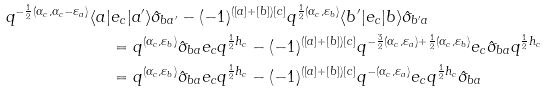Convert formula to latex. <formula><loc_0><loc_0><loc_500><loc_500>q ^ { - \frac { 1 } { 2 } ( \alpha _ { c } , \alpha _ { c } - \varepsilon _ { a } ) } \langle a | & e _ { c } | a ^ { \prime } \rangle \hat { \sigma } _ { b a ^ { \prime } } - ( - 1 ) ^ { ( [ a ] + [ b ] ) [ c ] } q ^ { \frac { 1 } { 2 } ( \alpha _ { c } , \varepsilon _ { b } ) } \langle b ^ { \prime } | e _ { c } | b \rangle \hat { \sigma } _ { b ^ { \prime } a } \\ & = q ^ { ( \alpha _ { c } , \varepsilon _ { b } ) } \hat { \sigma } _ { b a } e _ { c } q ^ { \frac { 1 } { 2 } h _ { c } } - ( - 1 ) ^ { ( [ a ] + [ b ] ) [ c ] } q ^ { - \frac { 3 } { 2 } ( \alpha _ { c } , \varepsilon _ { a } ) + \frac { 1 } { 2 } ( \alpha _ { c } , \varepsilon _ { b } ) } e _ { c } \hat { \sigma } _ { b a } q ^ { \frac { 1 } { 2 } h _ { c } } \\ & = q ^ { ( \alpha _ { c } , \varepsilon _ { b } ) } \hat { \sigma } _ { b a } e _ { c } q ^ { \frac { 1 } { 2 } h _ { c } } - ( - 1 ) ^ { ( [ a ] + [ b ] ) [ c ] } q ^ { - ( \alpha _ { c } , \varepsilon _ { a } ) } e _ { c } q ^ { \frac { 1 } { 2 } h _ { c } } \hat { \sigma } _ { b a }</formula> 